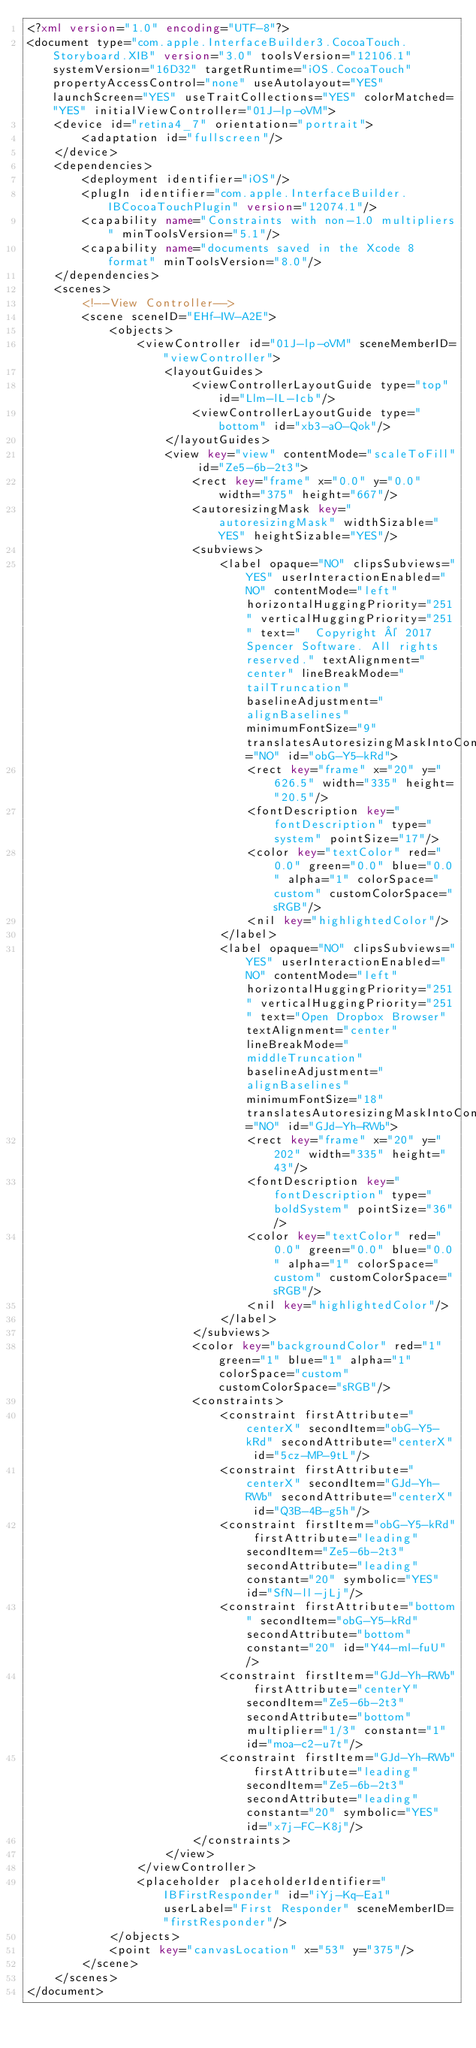Convert code to text. <code><loc_0><loc_0><loc_500><loc_500><_XML_><?xml version="1.0" encoding="UTF-8"?>
<document type="com.apple.InterfaceBuilder3.CocoaTouch.Storyboard.XIB" version="3.0" toolsVersion="12106.1" systemVersion="16D32" targetRuntime="iOS.CocoaTouch" propertyAccessControl="none" useAutolayout="YES" launchScreen="YES" useTraitCollections="YES" colorMatched="YES" initialViewController="01J-lp-oVM">
    <device id="retina4_7" orientation="portrait">
        <adaptation id="fullscreen"/>
    </device>
    <dependencies>
        <deployment identifier="iOS"/>
        <plugIn identifier="com.apple.InterfaceBuilder.IBCocoaTouchPlugin" version="12074.1"/>
        <capability name="Constraints with non-1.0 multipliers" minToolsVersion="5.1"/>
        <capability name="documents saved in the Xcode 8 format" minToolsVersion="8.0"/>
    </dependencies>
    <scenes>
        <!--View Controller-->
        <scene sceneID="EHf-IW-A2E">
            <objects>
                <viewController id="01J-lp-oVM" sceneMemberID="viewController">
                    <layoutGuides>
                        <viewControllerLayoutGuide type="top" id="Llm-lL-Icb"/>
                        <viewControllerLayoutGuide type="bottom" id="xb3-aO-Qok"/>
                    </layoutGuides>
                    <view key="view" contentMode="scaleToFill" id="Ze5-6b-2t3">
                        <rect key="frame" x="0.0" y="0.0" width="375" height="667"/>
                        <autoresizingMask key="autoresizingMask" widthSizable="YES" heightSizable="YES"/>
                        <subviews>
                            <label opaque="NO" clipsSubviews="YES" userInteractionEnabled="NO" contentMode="left" horizontalHuggingPriority="251" verticalHuggingPriority="251" text="  Copyright © 2017 Spencer Software. All rights reserved." textAlignment="center" lineBreakMode="tailTruncation" baselineAdjustment="alignBaselines" minimumFontSize="9" translatesAutoresizingMaskIntoConstraints="NO" id="obG-Y5-kRd">
                                <rect key="frame" x="20" y="626.5" width="335" height="20.5"/>
                                <fontDescription key="fontDescription" type="system" pointSize="17"/>
                                <color key="textColor" red="0.0" green="0.0" blue="0.0" alpha="1" colorSpace="custom" customColorSpace="sRGB"/>
                                <nil key="highlightedColor"/>
                            </label>
                            <label opaque="NO" clipsSubviews="YES" userInteractionEnabled="NO" contentMode="left" horizontalHuggingPriority="251" verticalHuggingPriority="251" text="Open Dropbox Browser" textAlignment="center" lineBreakMode="middleTruncation" baselineAdjustment="alignBaselines" minimumFontSize="18" translatesAutoresizingMaskIntoConstraints="NO" id="GJd-Yh-RWb">
                                <rect key="frame" x="20" y="202" width="335" height="43"/>
                                <fontDescription key="fontDescription" type="boldSystem" pointSize="36"/>
                                <color key="textColor" red="0.0" green="0.0" blue="0.0" alpha="1" colorSpace="custom" customColorSpace="sRGB"/>
                                <nil key="highlightedColor"/>
                            </label>
                        </subviews>
                        <color key="backgroundColor" red="1" green="1" blue="1" alpha="1" colorSpace="custom" customColorSpace="sRGB"/>
                        <constraints>
                            <constraint firstAttribute="centerX" secondItem="obG-Y5-kRd" secondAttribute="centerX" id="5cz-MP-9tL"/>
                            <constraint firstAttribute="centerX" secondItem="GJd-Yh-RWb" secondAttribute="centerX" id="Q3B-4B-g5h"/>
                            <constraint firstItem="obG-Y5-kRd" firstAttribute="leading" secondItem="Ze5-6b-2t3" secondAttribute="leading" constant="20" symbolic="YES" id="SfN-ll-jLj"/>
                            <constraint firstAttribute="bottom" secondItem="obG-Y5-kRd" secondAttribute="bottom" constant="20" id="Y44-ml-fuU"/>
                            <constraint firstItem="GJd-Yh-RWb" firstAttribute="centerY" secondItem="Ze5-6b-2t3" secondAttribute="bottom" multiplier="1/3" constant="1" id="moa-c2-u7t"/>
                            <constraint firstItem="GJd-Yh-RWb" firstAttribute="leading" secondItem="Ze5-6b-2t3" secondAttribute="leading" constant="20" symbolic="YES" id="x7j-FC-K8j"/>
                        </constraints>
                    </view>
                </viewController>
                <placeholder placeholderIdentifier="IBFirstResponder" id="iYj-Kq-Ea1" userLabel="First Responder" sceneMemberID="firstResponder"/>
            </objects>
            <point key="canvasLocation" x="53" y="375"/>
        </scene>
    </scenes>
</document>
</code> 